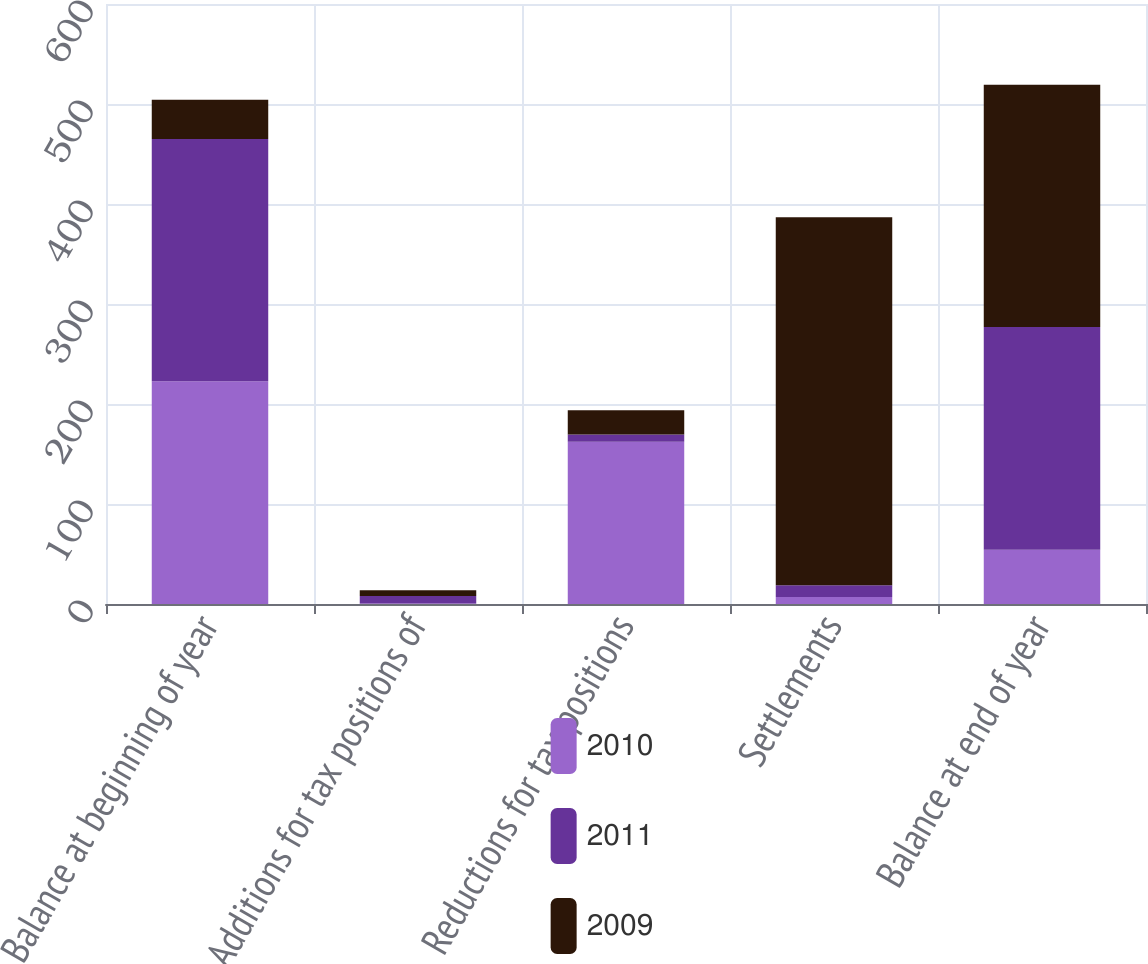<chart> <loc_0><loc_0><loc_500><loc_500><stacked_bar_chart><ecel><fcel>Balance at beginning of year<fcel>Additions for tax positions of<fcel>Reductions for tax positions<fcel>Settlements<fcel>Balance at end of year<nl><fcel>2010<fcel>222.8<fcel>0.6<fcel>162.2<fcel>6.9<fcel>54.3<nl><fcel>2011<fcel>242.2<fcel>7.5<fcel>7.4<fcel>11.9<fcel>222.8<nl><fcel>2009<fcel>39.2<fcel>5.6<fcel>24.1<fcel>367.9<fcel>242.2<nl></chart> 